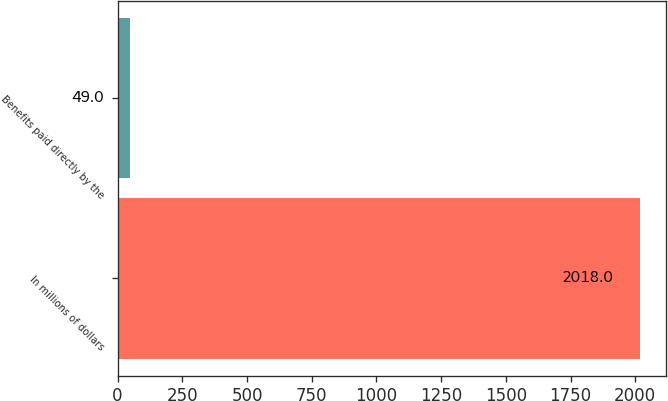Convert chart. <chart><loc_0><loc_0><loc_500><loc_500><bar_chart><fcel>In millions of dollars<fcel>Benefits paid directly by the<nl><fcel>2018<fcel>49<nl></chart> 